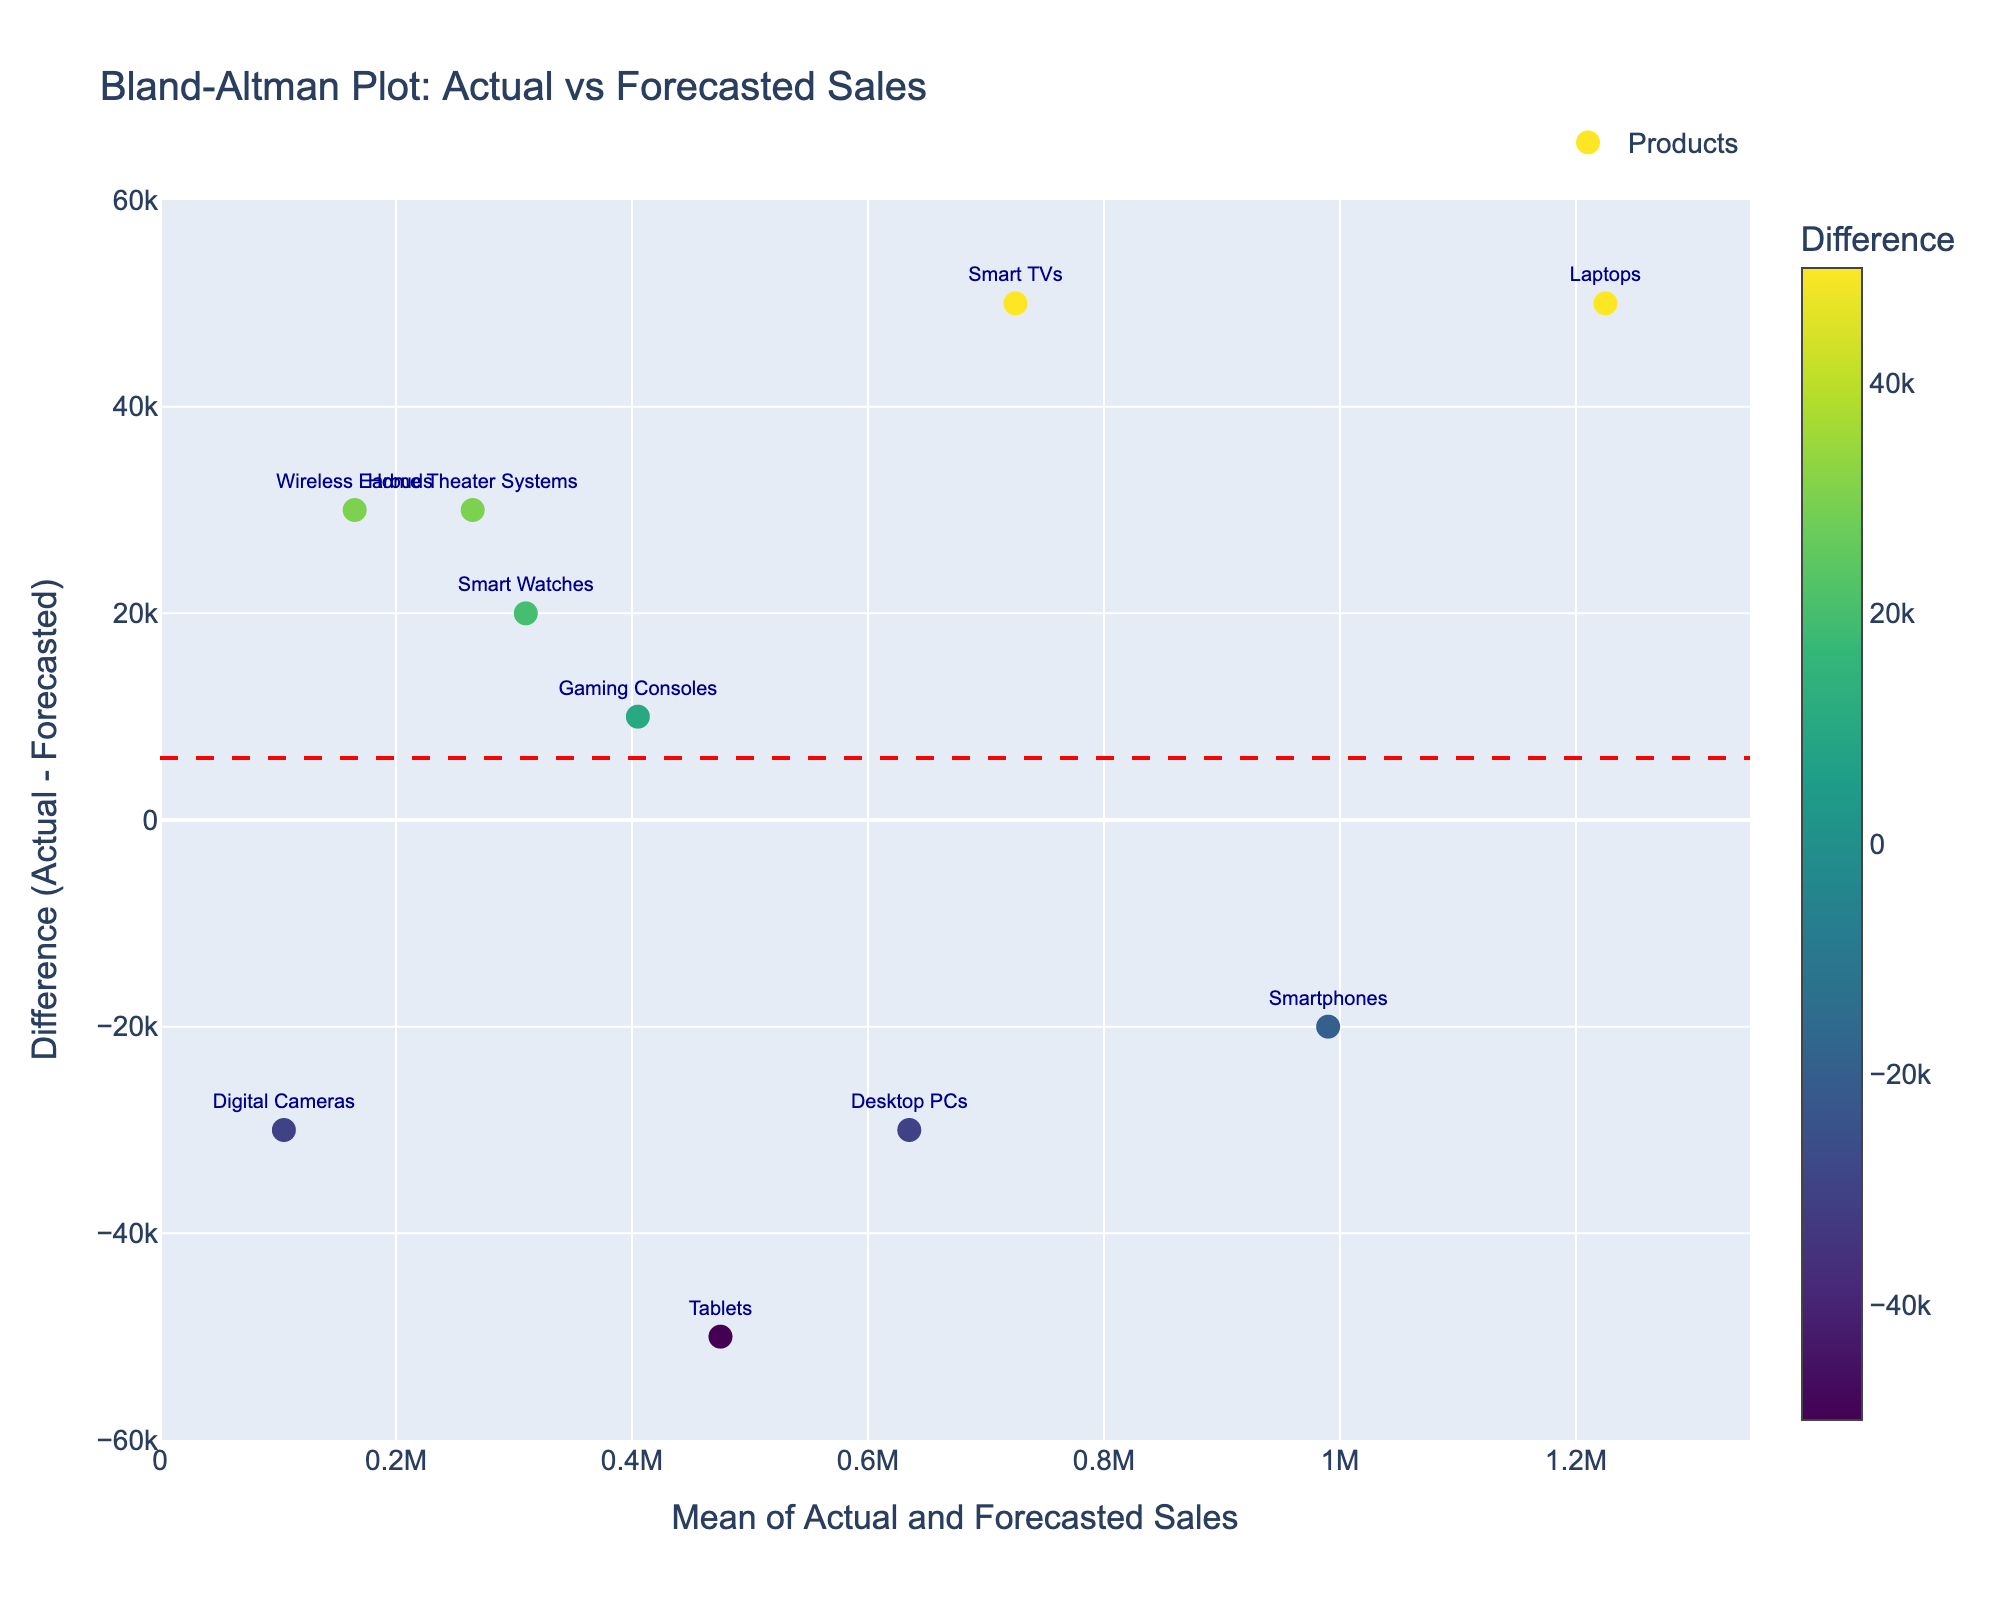What is the title of the plot? The title is found at the top of the plot and provides an overall description of what the plot represents. It allows viewers to quickly understand the context of the visualization.
Answer: Bland-Altman Plot: Actual vs Forecasted Sales How many product lines are displayed on the plot? Each marker on the plot represents a product line, with text labels for each. By counting these markers or labels, one can determine the number of product lines.
Answer: 10 What does the red dashed line in the plot represent? The red dashed line represents the mean difference between actual and forecasted sales values. It provides a reference point for understanding the average deviation from the forecast.
Answer: Mean difference Which product line has the largest deviation between actual and forecasted sales? To identify the product line with the largest deviation, look for the marker that is farthest from the red dashed line on the y-axis, either above or below.
Answer: Wireless Earbuds What is the mean of the actual sales for Smart Watches and Tablets? Find the actual sales values for Smart Watches and Tablets, then calculate their average. This involves summing the actual sales values for these products and dividing by two. (320000 for Smart Watches and 450000 for Tablets, so the mean is (320000 + 450000) / 2).
Answer: 385000 Which product has the smallest difference between actual and forecasted sales? The smallest difference is found by locating the data point closest to the red dashed line on the y-axis. This point represents the product with the least deviation from its forecasted value.
Answer: Gaming Consoles How does the sales difference for Laptops compare to that of Smart TVs? Compare the y-values (difference between actual and forecasted sales) for Laptops and Smart TVs. Laptops should have a higher or lower difference compared to Smart TVs.
Answer: Laptops have a greater sales difference What do the green dotted lines represent? The green lines are often used to show the limits of agreement, which are set at the mean difference ± 1.96 times the standard deviation. These lines help visualize the range within which most differences between actual and forecasted sales are expected to fall.
Answer: Limits of agreement Which product line is closest to the mean difference? Identify the product line whose marker is closest to the red dashed line on the y-axis, indicating its difference is closest to the mean difference.
Answer: Digital Cameras 